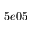<formula> <loc_0><loc_0><loc_500><loc_500>5 e 0 5</formula> 